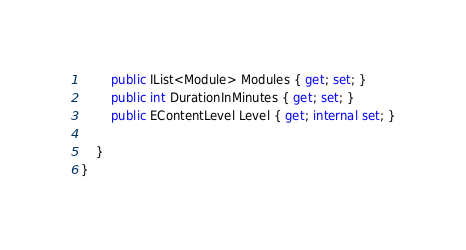Convert code to text. <code><loc_0><loc_0><loc_500><loc_500><_C#_>        public IList<Module> Modules { get; set; }
        public int DurationInMinutes { get; set; }
        public EContentLevel Level { get; internal set; }

    }
}</code> 